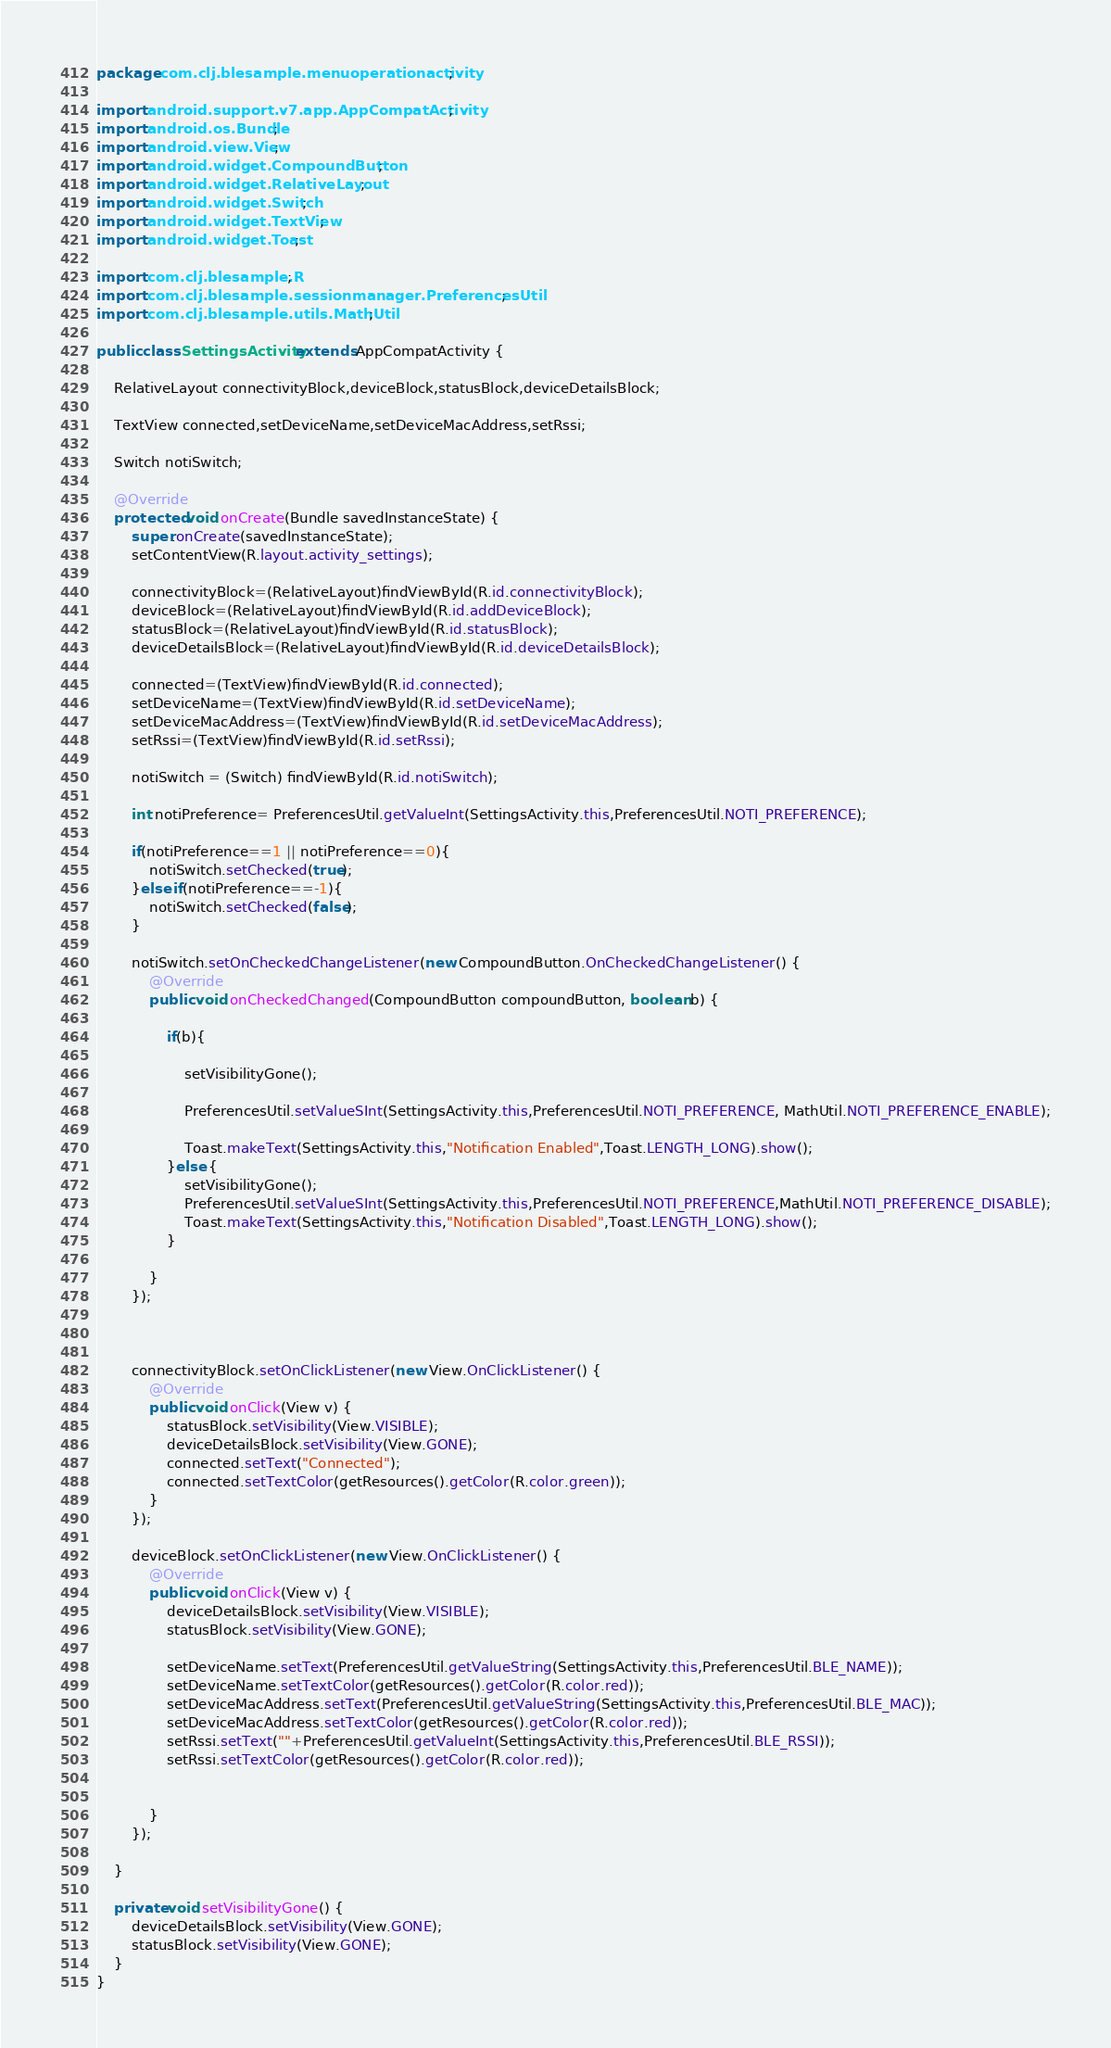<code> <loc_0><loc_0><loc_500><loc_500><_Java_>package com.clj.blesample.menuoperationactivity;

import android.support.v7.app.AppCompatActivity;
import android.os.Bundle;
import android.view.View;
import android.widget.CompoundButton;
import android.widget.RelativeLayout;
import android.widget.Switch;
import android.widget.TextView;
import android.widget.Toast;

import com.clj.blesample.R;
import com.clj.blesample.sessionmanager.PreferencesUtil;
import com.clj.blesample.utils.MathUtil;

public class SettingsActivity extends AppCompatActivity {

    RelativeLayout connectivityBlock,deviceBlock,statusBlock,deviceDetailsBlock;

    TextView connected,setDeviceName,setDeviceMacAddress,setRssi;

    Switch notiSwitch;

    @Override
    protected void onCreate(Bundle savedInstanceState) {
        super.onCreate(savedInstanceState);
        setContentView(R.layout.activity_settings);

        connectivityBlock=(RelativeLayout)findViewById(R.id.connectivityBlock);
        deviceBlock=(RelativeLayout)findViewById(R.id.addDeviceBlock);
        statusBlock=(RelativeLayout)findViewById(R.id.statusBlock);
        deviceDetailsBlock=(RelativeLayout)findViewById(R.id.deviceDetailsBlock);

        connected=(TextView)findViewById(R.id.connected);
        setDeviceName=(TextView)findViewById(R.id.setDeviceName);
        setDeviceMacAddress=(TextView)findViewById(R.id.setDeviceMacAddress);
        setRssi=(TextView)findViewById(R.id.setRssi);

        notiSwitch = (Switch) findViewById(R.id.notiSwitch);

        int notiPreference= PreferencesUtil.getValueInt(SettingsActivity.this,PreferencesUtil.NOTI_PREFERENCE);

        if(notiPreference==1 || notiPreference==0){
            notiSwitch.setChecked(true);
        }else if(notiPreference==-1){
            notiSwitch.setChecked(false);
        }

        notiSwitch.setOnCheckedChangeListener(new CompoundButton.OnCheckedChangeListener() {
            @Override
            public void onCheckedChanged(CompoundButton compoundButton, boolean b) {

                if(b){

                    setVisibilityGone();

                    PreferencesUtil.setValueSInt(SettingsActivity.this,PreferencesUtil.NOTI_PREFERENCE, MathUtil.NOTI_PREFERENCE_ENABLE);

                    Toast.makeText(SettingsActivity.this,"Notification Enabled",Toast.LENGTH_LONG).show();
                }else {
                    setVisibilityGone();
                    PreferencesUtil.setValueSInt(SettingsActivity.this,PreferencesUtil.NOTI_PREFERENCE,MathUtil.NOTI_PREFERENCE_DISABLE);
                    Toast.makeText(SettingsActivity.this,"Notification Disabled",Toast.LENGTH_LONG).show();
                }

            }
        });



        connectivityBlock.setOnClickListener(new View.OnClickListener() {
            @Override
            public void onClick(View v) {
                statusBlock.setVisibility(View.VISIBLE);
                deviceDetailsBlock.setVisibility(View.GONE);
                connected.setText("Connected");
                connected.setTextColor(getResources().getColor(R.color.green));
            }
        });

        deviceBlock.setOnClickListener(new View.OnClickListener() {
            @Override
            public void onClick(View v) {
                deviceDetailsBlock.setVisibility(View.VISIBLE);
                statusBlock.setVisibility(View.GONE);

                setDeviceName.setText(PreferencesUtil.getValueString(SettingsActivity.this,PreferencesUtil.BLE_NAME));
                setDeviceName.setTextColor(getResources().getColor(R.color.red));
                setDeviceMacAddress.setText(PreferencesUtil.getValueString(SettingsActivity.this,PreferencesUtil.BLE_MAC));
                setDeviceMacAddress.setTextColor(getResources().getColor(R.color.red));
                setRssi.setText(""+PreferencesUtil.getValueInt(SettingsActivity.this,PreferencesUtil.BLE_RSSI));
                setRssi.setTextColor(getResources().getColor(R.color.red));


            }
        });

    }

    private void setVisibilityGone() {
        deviceDetailsBlock.setVisibility(View.GONE);
        statusBlock.setVisibility(View.GONE);
    }
}</code> 